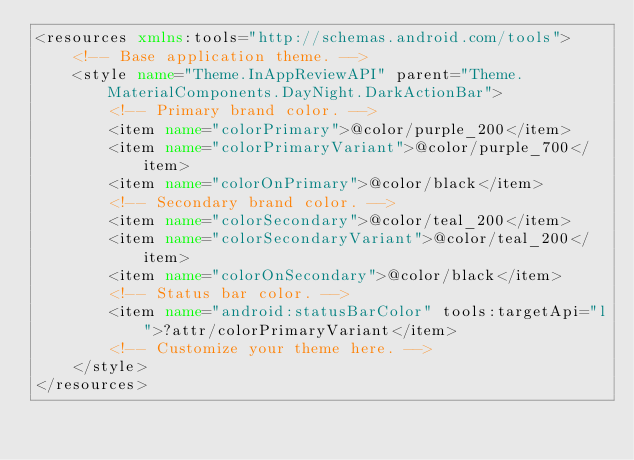<code> <loc_0><loc_0><loc_500><loc_500><_XML_><resources xmlns:tools="http://schemas.android.com/tools">
    <!-- Base application theme. -->
    <style name="Theme.InAppReviewAPI" parent="Theme.MaterialComponents.DayNight.DarkActionBar">
        <!-- Primary brand color. -->
        <item name="colorPrimary">@color/purple_200</item>
        <item name="colorPrimaryVariant">@color/purple_700</item>
        <item name="colorOnPrimary">@color/black</item>
        <!-- Secondary brand color. -->
        <item name="colorSecondary">@color/teal_200</item>
        <item name="colorSecondaryVariant">@color/teal_200</item>
        <item name="colorOnSecondary">@color/black</item>
        <!-- Status bar color. -->
        <item name="android:statusBarColor" tools:targetApi="l">?attr/colorPrimaryVariant</item>
        <!-- Customize your theme here. -->
    </style>
</resources></code> 